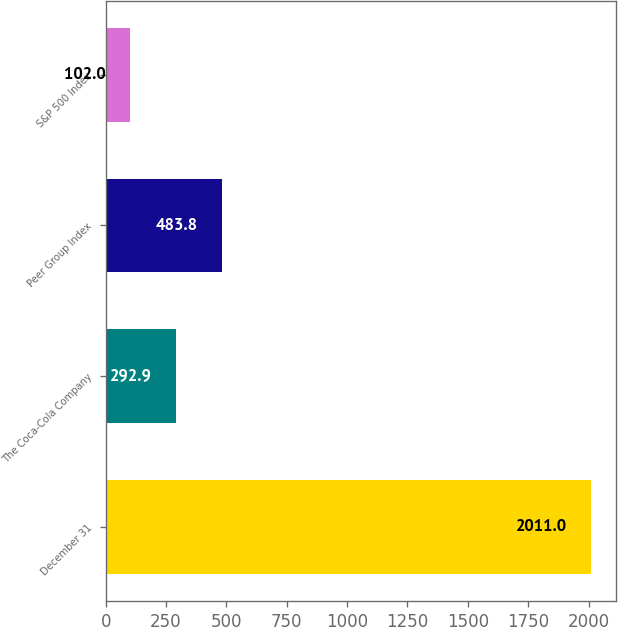Convert chart to OTSL. <chart><loc_0><loc_0><loc_500><loc_500><bar_chart><fcel>December 31<fcel>The Coca-Cola Company<fcel>Peer Group Index<fcel>S&P 500 Index<nl><fcel>2011<fcel>292.9<fcel>483.8<fcel>102<nl></chart> 